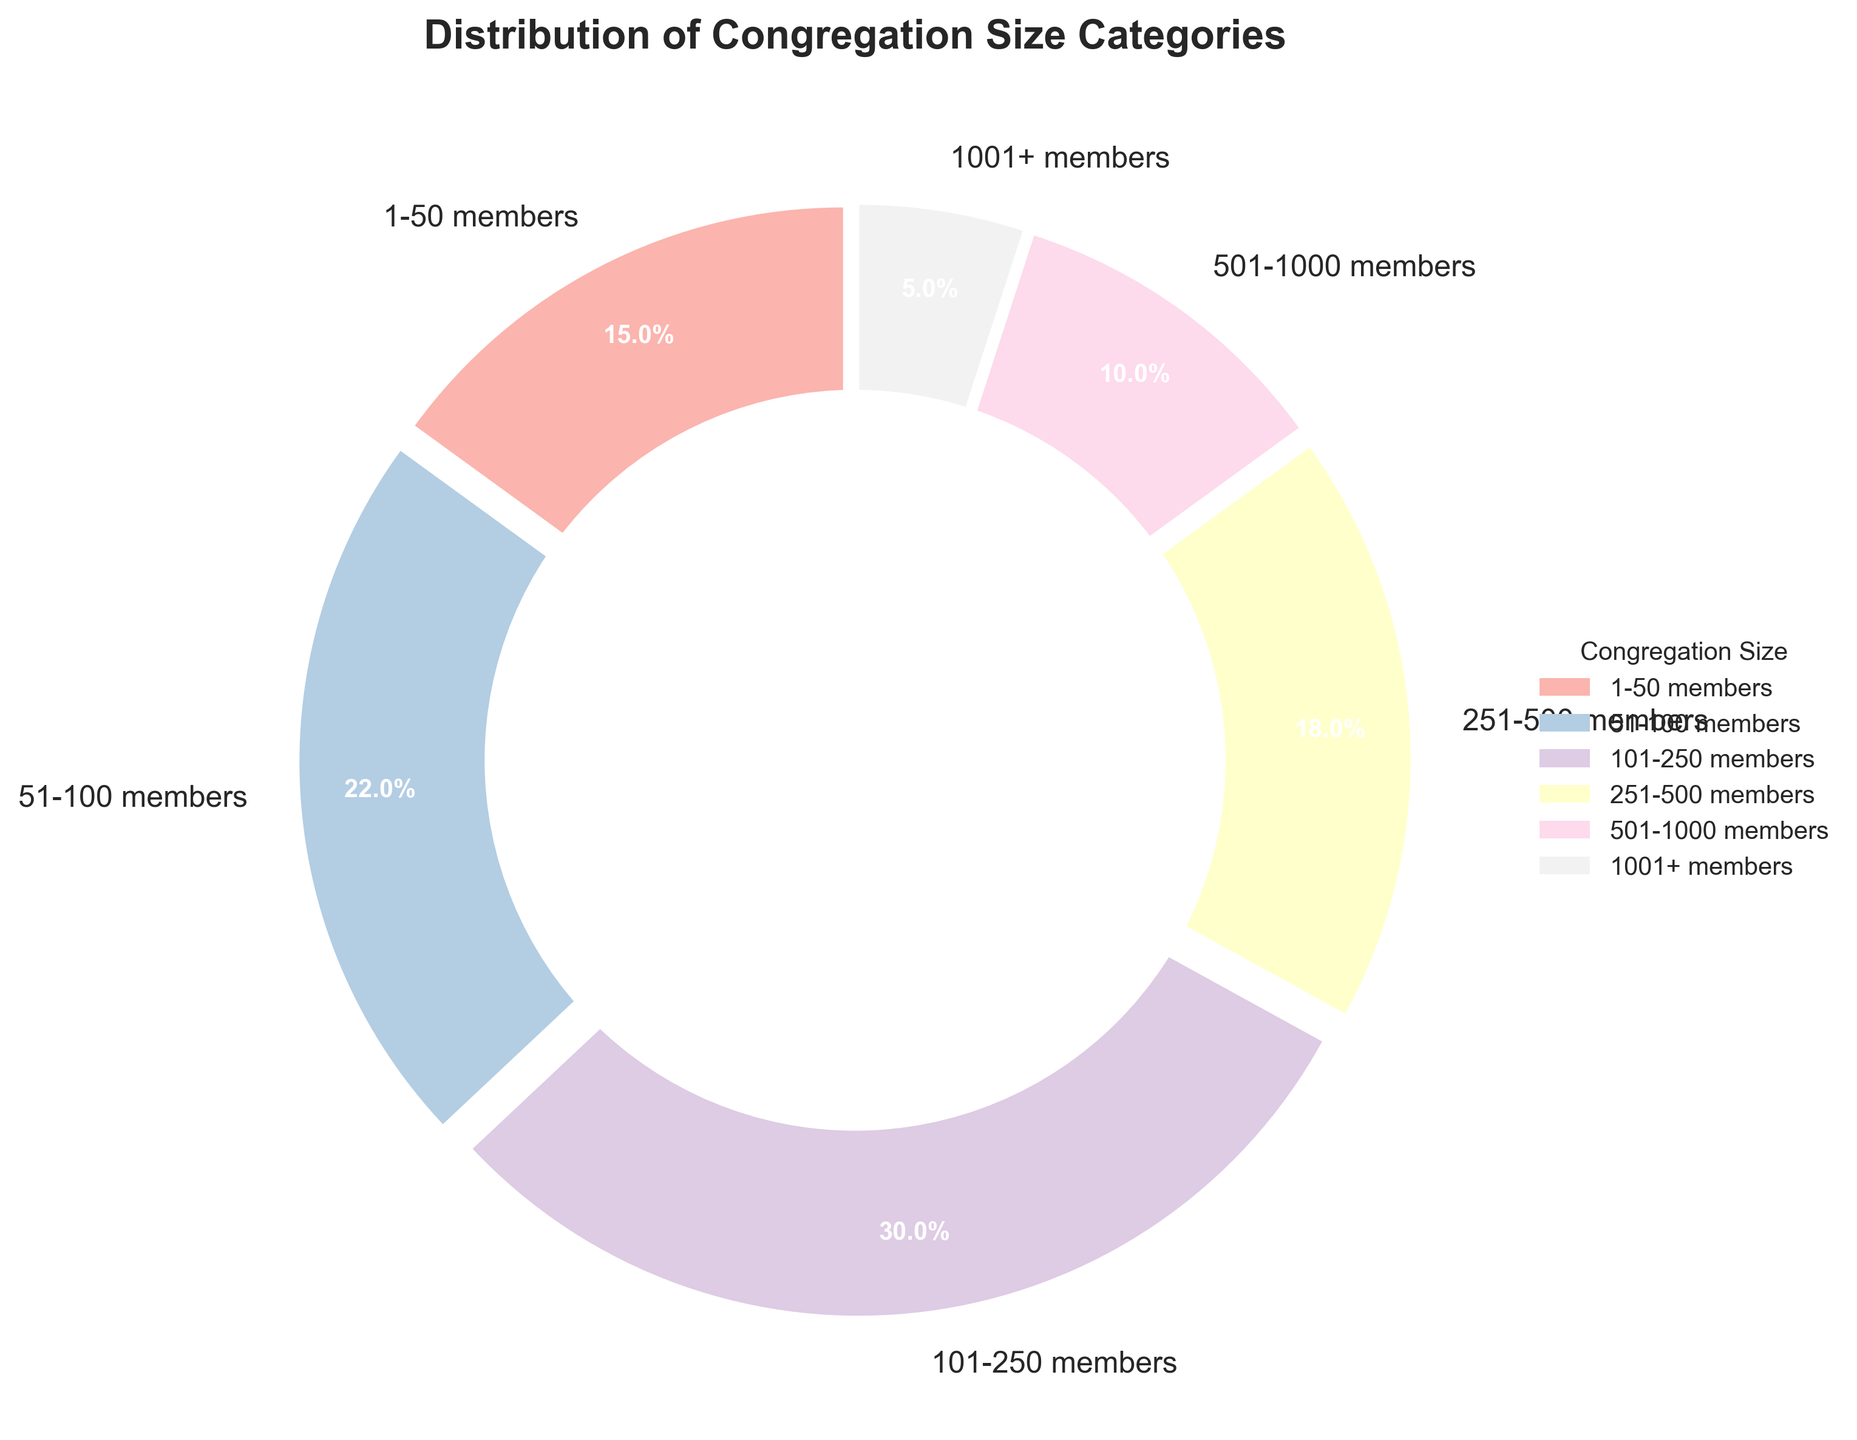Which congregation size category has the largest percentage? The segment '101-250 members' has a larger wedge compared to the others, indicated as 30%. This is the largest percentage in the pie chart.
Answer: 101-250 members What is the combined percentage of congregations with 100 or fewer members? Add the percentages of '1-50 members' (15%) and '51-100 members' (22%) to get the total percentage. 15% + 22% = 37%.
Answer: 37% How much larger is the percentage of congregations with 101-250 members compared to those with 251-500 members? Subtract the percentage of '251-500 members' (18%) from '101-250 members' (30%). 30% - 18% = 12%.
Answer: 12% Which category has the smallest percentage? The segment '1001+ members' has the smallest wedge, indicated as 5%. This is the smallest percentage in the pie chart.
Answer: 1001+ members Is the percentage of congregations with 51-100 members greater than those with 501-1000 members? The wedge for '51-100 members' is labeled as 22%, while '501-1000 members' is labeled as 10%. Since 22% is greater than 10%, the percentage of '51-100 members' is indeed greater.
Answer: Yes What is the total percentage of congregations with more than 500 members? Add the percentages of '501-1000 members' (10%) and '1001+ members' (5%) to get the total percentage. 10% + 5% = 15%.
Answer: 15% Which segments of the pie chart are shown in pastel colors and how is the visual gap between wedges? All segments (six in total) are depicted in pastel colors with a slight visual gap created by the explode feature. The uniform gap ensures each segment is distinguishable.
Answer: All segments What fraction of the congregations has between 1 and 250 members? Add the percentages for '1-50 members' (15%), '51-100 members' (22%), and '101-250 members' (30%). 15% + 22% + 30% = 67%.
Answer: 67% How does the segment for congregations with 1001+ members compare visually to the segment for 1-50 members? The wedge for '1001+ members' (5%) is much smaller and occupies less space in the chart compared to the wedge for '1-50 members' (15%).
Answer: Smaller 